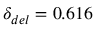Convert formula to latex. <formula><loc_0><loc_0><loc_500><loc_500>\delta _ { d e l } = 0 . 6 1 6</formula> 